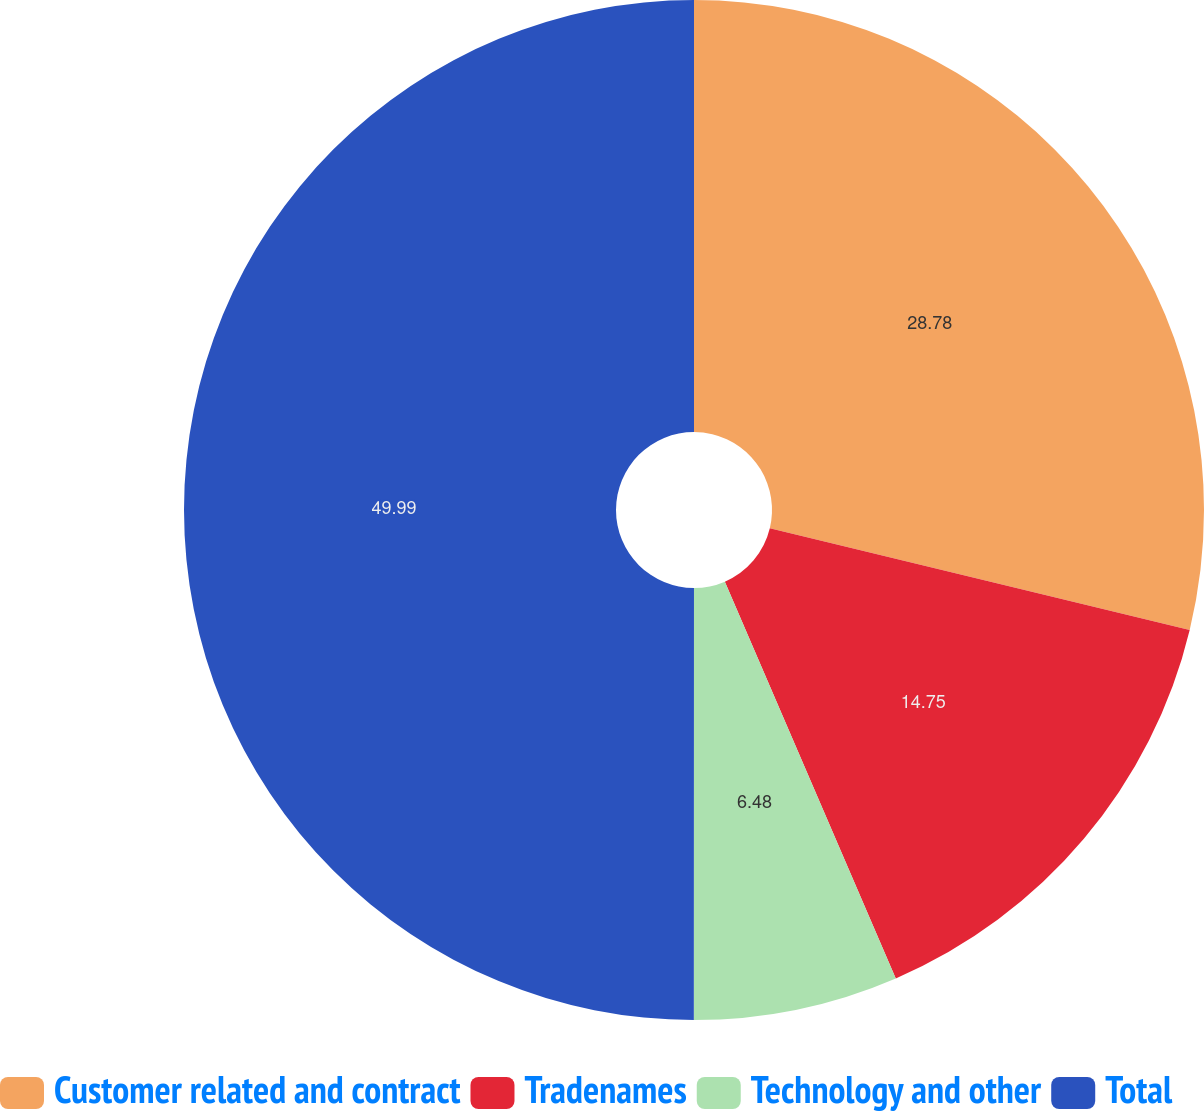<chart> <loc_0><loc_0><loc_500><loc_500><pie_chart><fcel>Customer related and contract<fcel>Tradenames<fcel>Technology and other<fcel>Total<nl><fcel>28.78%<fcel>14.75%<fcel>6.48%<fcel>50.0%<nl></chart> 